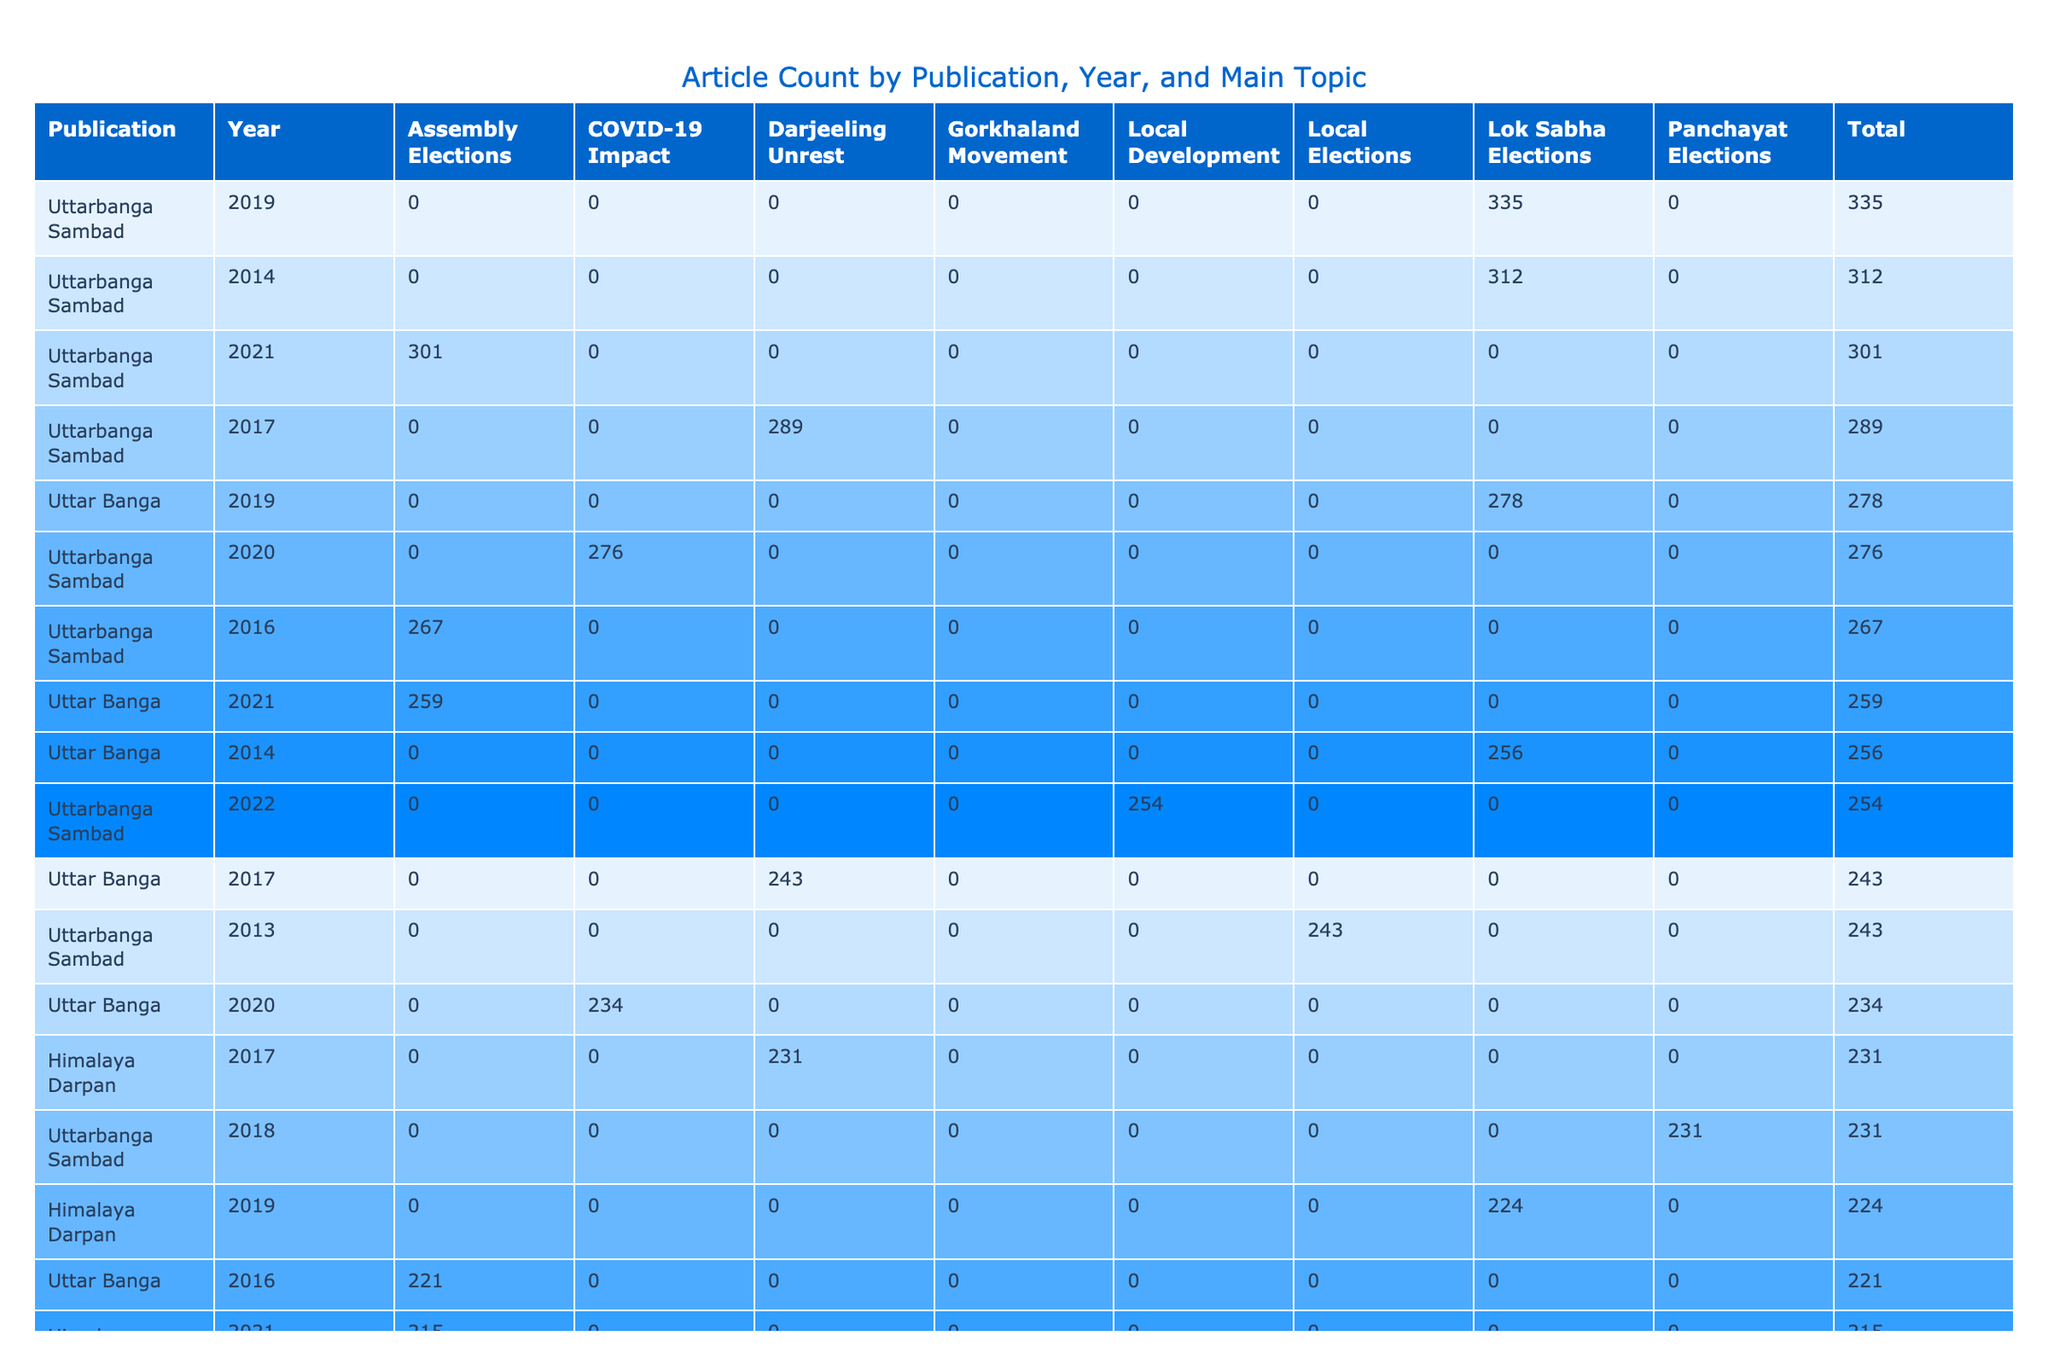What was the publication with the highest total article count in 2019? By reviewing the total numbers for each publication in the year 2019, we see that Uttarbanga Sambad has an article count of 335, which is higher than any other publication for that year.
Answer: Uttarbanga Sambad Which publication had the lowest positive sentiment score in 2020? In the data for 2020, we find that Janpath Samachar has a positive sentiment score of 29, which is lower than the other publications: Uttarbanga Sambad (45), Uttar Banga (39), and Himalaya Darpan (34).
Answer: Janpath Samachar What is the average article count for the publication Uttarbanga Sambad over the years provided? The article counts for Uttarbanga Sambad are 243, 312, 198, 267, 289, 231, 335, 276, 301, and 254. To find the average, we sum these values (243 + 312 + 198 + 267 + 289 + 231 + 335 + 276 + 301 + 254 = 2,674) and divide by 10 years, giving an average of 267.4.
Answer: 267.4 Did any publication consistently have a negative sentiment score above 50 in multiple years? By analyzing the negative sentiment scores across publications, we see that Uttarbanga Sambad had a negative sentiment of 63 in 2014, 72 in 2017, and 64 in 2021, indicating it had scores above 50 in those years.
Answer: Yes What was the total article count for all publications on the topic of 'Lok Sabha Elections' in 2014? We need to identify the article counts from each publication for the year 2014 with the topic of 'Lok Sabha Elections': Uttarbanga Sambad (62), Uttar Banga (54), Himalaya Darpan (47), and Janpath Samachar (39). Adding these gives us a total of (62 + 54 + 47 + 39 = 202).
Answer: 202 